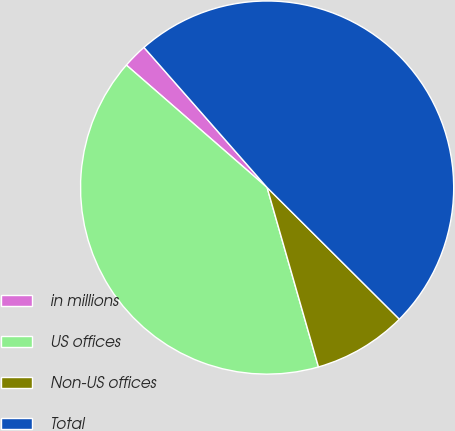Convert chart to OTSL. <chart><loc_0><loc_0><loc_500><loc_500><pie_chart><fcel>in millions<fcel>US offices<fcel>Non-US offices<fcel>Total<nl><fcel>2.13%<fcel>40.83%<fcel>8.1%<fcel>48.93%<nl></chart> 